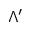Convert formula to latex. <formula><loc_0><loc_0><loc_500><loc_500>\Lambda ^ { \prime }</formula> 